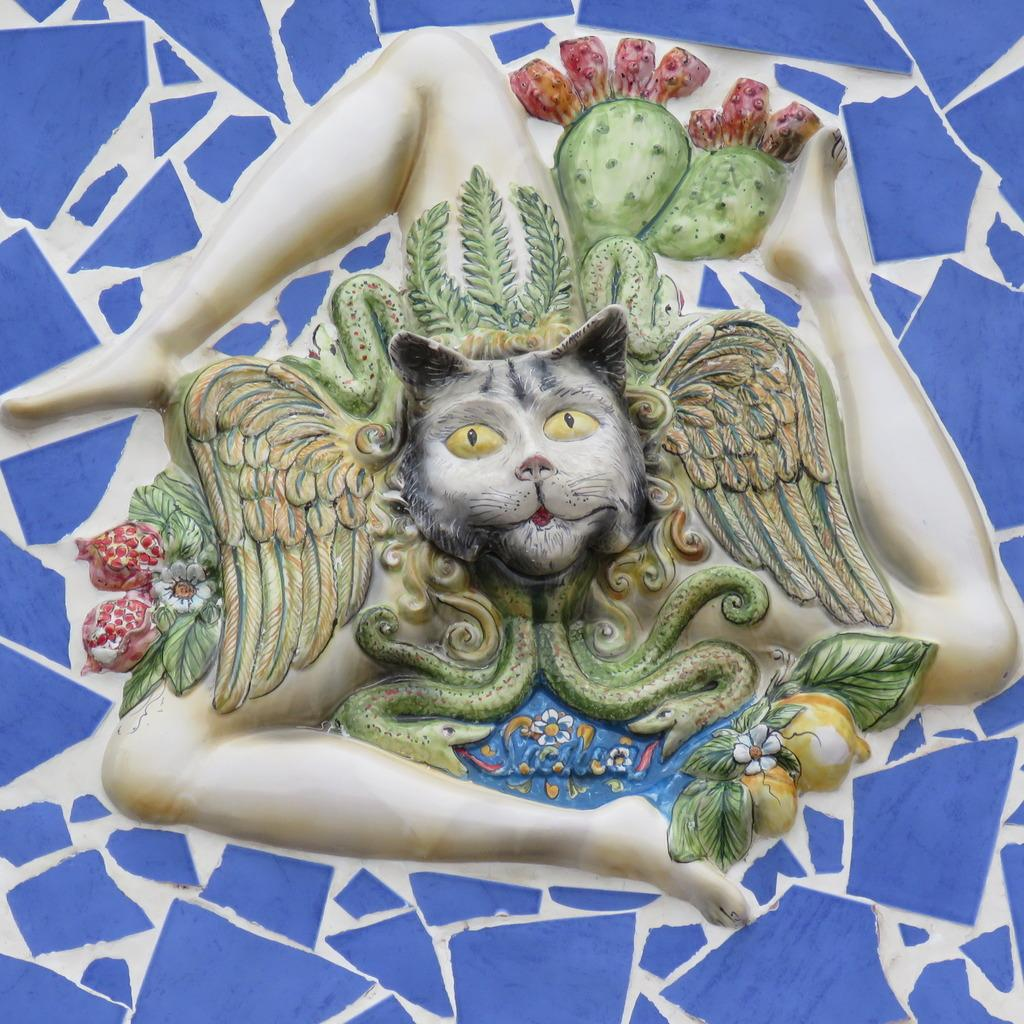What is the main subject of the picture? The main subject of the picture is a sculpture. What is the appearance of the sculpture's face? The sculpture has a cat's face. What can be seen behind the sculpture in the picture? There is a blue and white wall behind the sculpture. How many chickens are sitting on the word in the image? There are no chickens or words present in the image; it features a sculpture with a cat's face and a blue and white wall. What type of stick is being used by the sculpture in the image? There is no stick present in the image; the sculpture has a cat's face and is not holding or using any object. 